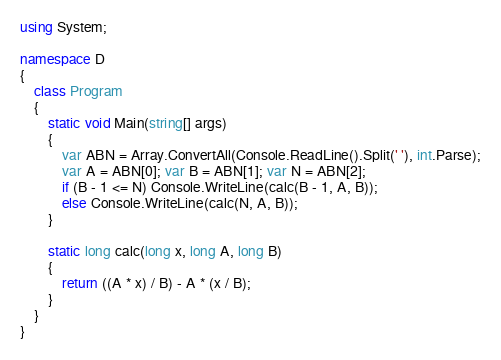Convert code to text. <code><loc_0><loc_0><loc_500><loc_500><_C#_>using System;

namespace D
{
    class Program
    {
        static void Main(string[] args)
        {
            var ABN = Array.ConvertAll(Console.ReadLine().Split(' '), int.Parse);
            var A = ABN[0]; var B = ABN[1]; var N = ABN[2];
            if (B - 1 <= N) Console.WriteLine(calc(B - 1, A, B));
            else Console.WriteLine(calc(N, A, B));
        }

        static long calc(long x, long A, long B)
        {
            return ((A * x) / B) - A * (x / B);
        }
    }
}
</code> 